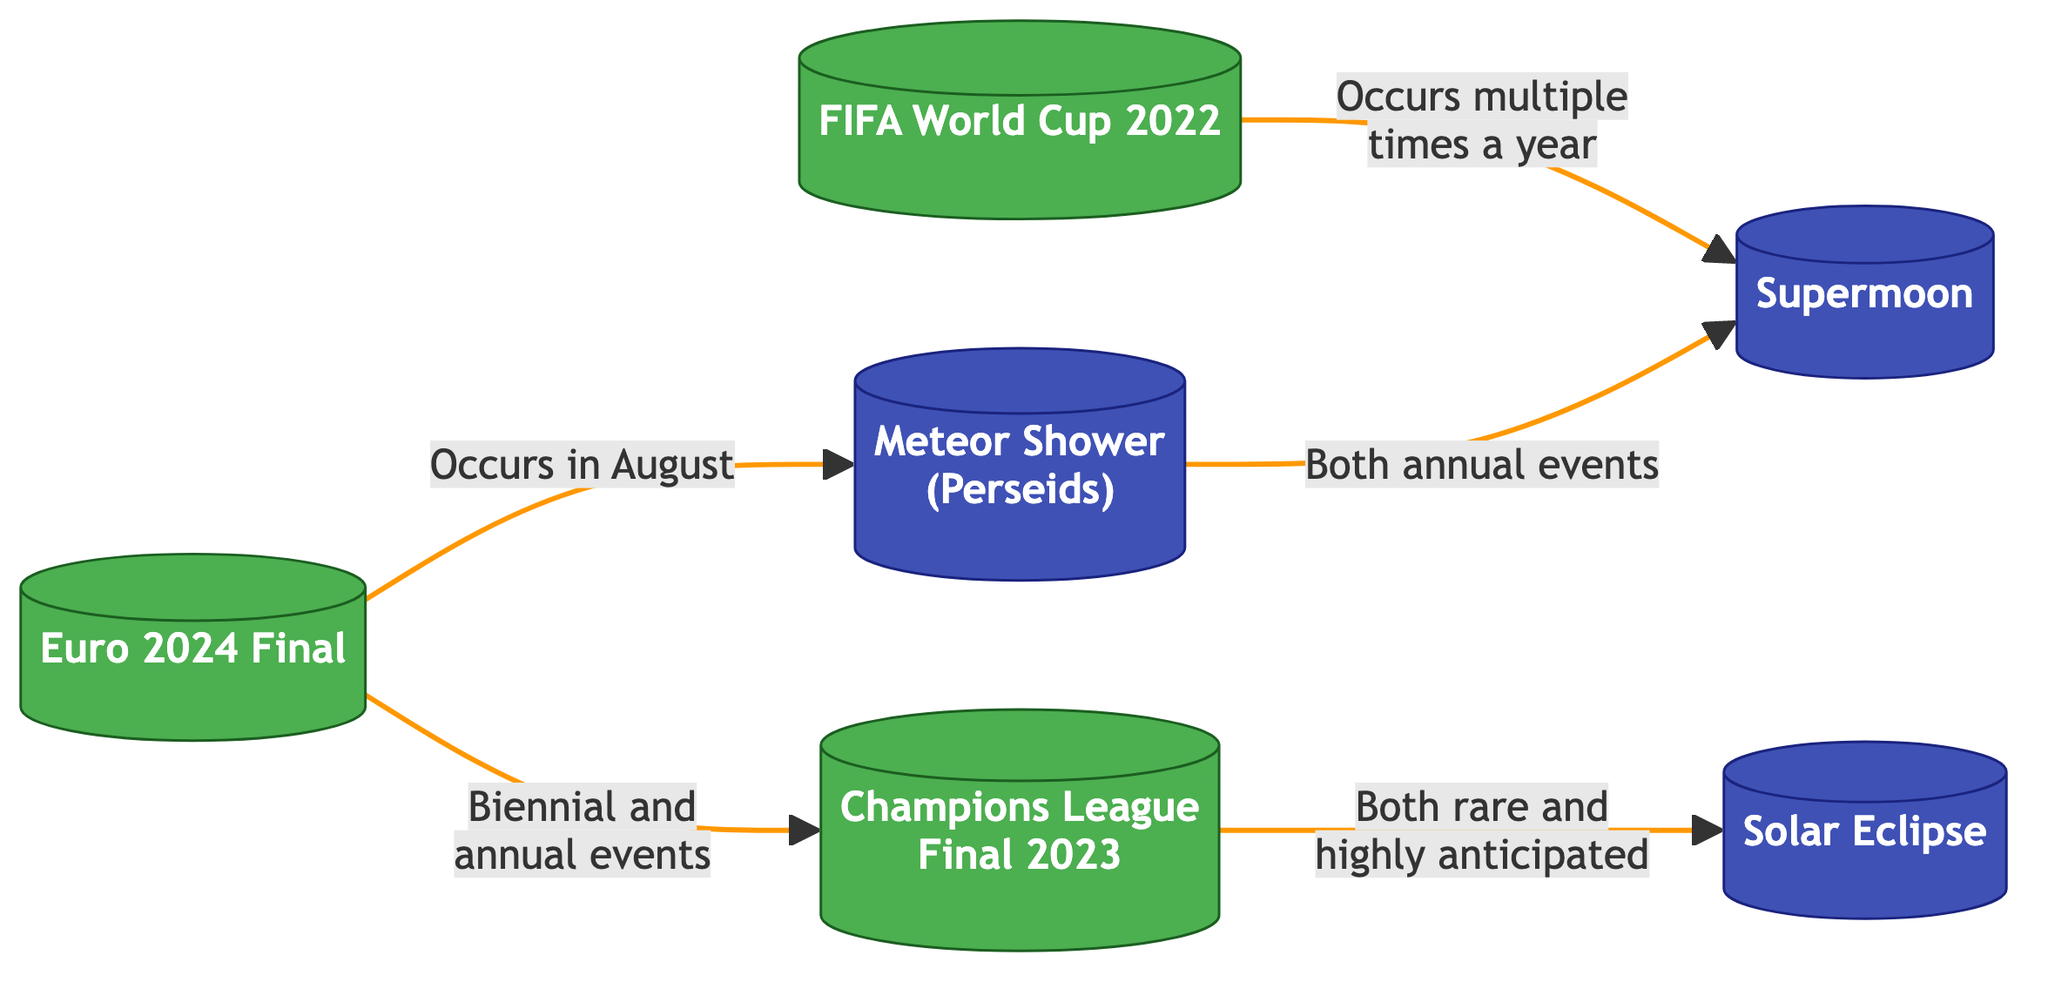What events occur in August? The diagram shows an arrow from "Euro 2024 Final" to "Meteor Shower (Perseids)" indicating that the Euro 2024 Final takes place in August.
Answer: Meteor Shower (Perseids) How many soccer events are shown in the diagram? The diagram lists three specific soccer events: "Euro 2024 Final," "FIFA World Cup 2022," and "Champions League Final 2023." Therefore, there are three nodes related to soccer.
Answer: 3 What connects both the "Champions League Final 2023" and the "Solar Eclipse"? The diagram indicates that "Champions League Final 2023" connects to "Solar Eclipse" with a statement identifying them both as rare and highly anticipated events.
Answer: Both rare and highly anticipated How many events are connected to the "Meteor Shower (Perseids)"? The diagram connects one event, "Euro 2024 Final," to "Meteor Shower (Perseids)," illustrating that there is one connection for this event.
Answer: 1 What type of events does the link between "FIFA World Cup 2022" and "Supermoon" describe? The diagram specifies that "FIFA World Cup 2022" occurs multiple times a year and connects to "Supermoon," categorizing it as an event that also happens multiple times annually.
Answer: Multiple times a year Which soccer event is a biennial event? The diagram indicates that the "Euro 2024 Final" is described as both a biennial and annual event, establishing it as a biennial one among the identified events.
Answer: Euro 2024 Final What are the characteristics shared by "Meteor Shower (Perseids)" and "Supermoon"? The diagram shows that both events are described as annual events, thus highlighting their frequency of occurrence as an important characteristic they share.
Answer: Annual events Which astronomical event occurs multiple times a year? The diagram connects "FIFA World Cup 2022" with "Supermoon" with the description that the World Cup occurs multiple times, but it does not specify this link in the context of any astronomical event. However, "Supermoon" is implied to occur multiple times as well, sharing its pattern.
Answer: Supermoon 